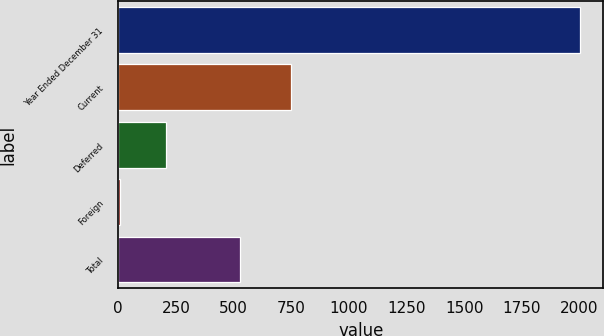Convert chart. <chart><loc_0><loc_0><loc_500><loc_500><bar_chart><fcel>Year Ended December 31<fcel>Current<fcel>Deferred<fcel>Foreign<fcel>Total<nl><fcel>2003<fcel>747<fcel>206.87<fcel>7.3<fcel>526.6<nl></chart> 